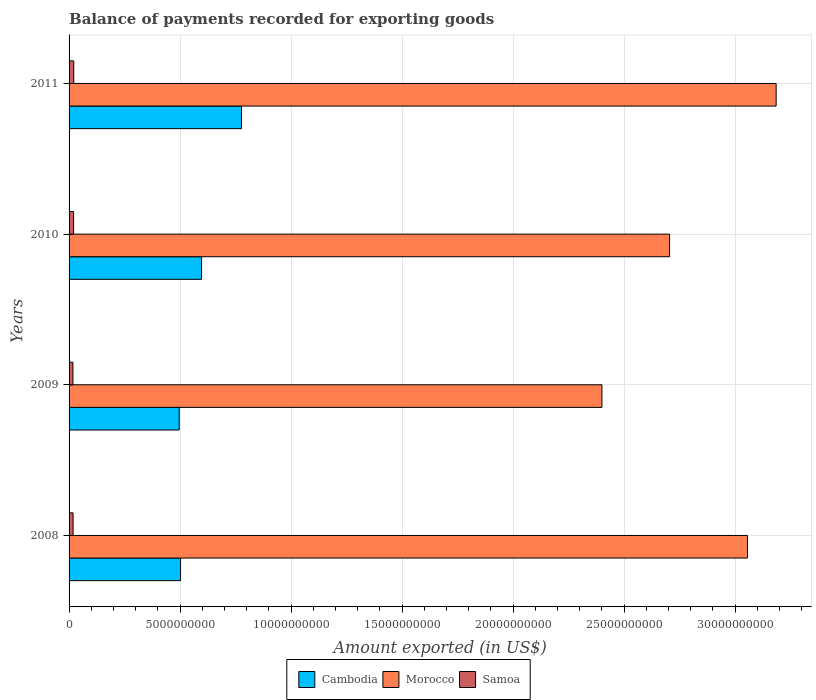How many groups of bars are there?
Provide a succinct answer. 4. Are the number of bars on each tick of the Y-axis equal?
Make the answer very short. Yes. How many bars are there on the 2nd tick from the top?
Make the answer very short. 3. How many bars are there on the 4th tick from the bottom?
Provide a succinct answer. 3. What is the amount exported in Cambodia in 2009?
Ensure brevity in your answer.  4.96e+09. Across all years, what is the maximum amount exported in Samoa?
Ensure brevity in your answer.  2.12e+08. Across all years, what is the minimum amount exported in Samoa?
Your answer should be compact. 1.74e+08. In which year was the amount exported in Morocco maximum?
Give a very brief answer. 2011. What is the total amount exported in Cambodia in the graph?
Your answer should be compact. 2.37e+1. What is the difference between the amount exported in Morocco in 2010 and that in 2011?
Provide a succinct answer. -4.80e+09. What is the difference between the amount exported in Samoa in 2010 and the amount exported in Cambodia in 2008?
Offer a terse response. -4.82e+09. What is the average amount exported in Samoa per year?
Your response must be concise. 1.92e+08. In the year 2011, what is the difference between the amount exported in Samoa and amount exported in Cambodia?
Offer a very short reply. -7.55e+09. In how many years, is the amount exported in Samoa greater than 5000000000 US$?
Make the answer very short. 0. What is the ratio of the amount exported in Cambodia in 2008 to that in 2010?
Make the answer very short. 0.84. Is the difference between the amount exported in Samoa in 2008 and 2009 greater than the difference between the amount exported in Cambodia in 2008 and 2009?
Your answer should be very brief. No. What is the difference between the highest and the second highest amount exported in Samoa?
Offer a very short reply. 8.14e+06. What is the difference between the highest and the lowest amount exported in Morocco?
Keep it short and to the point. 7.85e+09. Is the sum of the amount exported in Morocco in 2008 and 2011 greater than the maximum amount exported in Samoa across all years?
Keep it short and to the point. Yes. What does the 1st bar from the top in 2010 represents?
Keep it short and to the point. Samoa. What does the 2nd bar from the bottom in 2009 represents?
Your answer should be compact. Morocco. Is it the case that in every year, the sum of the amount exported in Morocco and amount exported in Cambodia is greater than the amount exported in Samoa?
Your answer should be compact. Yes. What is the difference between two consecutive major ticks on the X-axis?
Provide a short and direct response. 5.00e+09. Are the values on the major ticks of X-axis written in scientific E-notation?
Offer a terse response. No. Does the graph contain any zero values?
Your answer should be very brief. No. Does the graph contain grids?
Keep it short and to the point. Yes. What is the title of the graph?
Ensure brevity in your answer.  Balance of payments recorded for exporting goods. What is the label or title of the X-axis?
Provide a short and direct response. Amount exported (in US$). What is the Amount exported (in US$) of Cambodia in 2008?
Your response must be concise. 5.02e+09. What is the Amount exported (in US$) of Morocco in 2008?
Give a very brief answer. 3.06e+1. What is the Amount exported (in US$) in Samoa in 2008?
Provide a short and direct response. 1.80e+08. What is the Amount exported (in US$) of Cambodia in 2009?
Give a very brief answer. 4.96e+09. What is the Amount exported (in US$) in Morocco in 2009?
Ensure brevity in your answer.  2.40e+1. What is the Amount exported (in US$) of Samoa in 2009?
Provide a succinct answer. 1.74e+08. What is the Amount exported (in US$) in Cambodia in 2010?
Give a very brief answer. 5.97e+09. What is the Amount exported (in US$) of Morocco in 2010?
Make the answer very short. 2.70e+1. What is the Amount exported (in US$) in Samoa in 2010?
Your answer should be very brief. 2.04e+08. What is the Amount exported (in US$) in Cambodia in 2011?
Give a very brief answer. 7.76e+09. What is the Amount exported (in US$) in Morocco in 2011?
Offer a terse response. 3.18e+1. What is the Amount exported (in US$) of Samoa in 2011?
Provide a succinct answer. 2.12e+08. Across all years, what is the maximum Amount exported (in US$) of Cambodia?
Make the answer very short. 7.76e+09. Across all years, what is the maximum Amount exported (in US$) in Morocco?
Provide a short and direct response. 3.18e+1. Across all years, what is the maximum Amount exported (in US$) of Samoa?
Your response must be concise. 2.12e+08. Across all years, what is the minimum Amount exported (in US$) of Cambodia?
Your answer should be very brief. 4.96e+09. Across all years, what is the minimum Amount exported (in US$) of Morocco?
Provide a succinct answer. 2.40e+1. Across all years, what is the minimum Amount exported (in US$) in Samoa?
Your answer should be compact. 1.74e+08. What is the total Amount exported (in US$) of Cambodia in the graph?
Offer a very short reply. 2.37e+1. What is the total Amount exported (in US$) of Morocco in the graph?
Keep it short and to the point. 1.13e+11. What is the total Amount exported (in US$) of Samoa in the graph?
Make the answer very short. 7.69e+08. What is the difference between the Amount exported (in US$) of Cambodia in 2008 and that in 2009?
Provide a short and direct response. 6.08e+07. What is the difference between the Amount exported (in US$) of Morocco in 2008 and that in 2009?
Your answer should be compact. 6.56e+09. What is the difference between the Amount exported (in US$) in Samoa in 2008 and that in 2009?
Your answer should be compact. 6.53e+06. What is the difference between the Amount exported (in US$) in Cambodia in 2008 and that in 2010?
Give a very brief answer. -9.47e+08. What is the difference between the Amount exported (in US$) in Morocco in 2008 and that in 2010?
Your response must be concise. 3.51e+09. What is the difference between the Amount exported (in US$) of Samoa in 2008 and that in 2010?
Provide a short and direct response. -2.35e+07. What is the difference between the Amount exported (in US$) of Cambodia in 2008 and that in 2011?
Offer a terse response. -2.74e+09. What is the difference between the Amount exported (in US$) of Morocco in 2008 and that in 2011?
Your response must be concise. -1.29e+09. What is the difference between the Amount exported (in US$) in Samoa in 2008 and that in 2011?
Keep it short and to the point. -3.16e+07. What is the difference between the Amount exported (in US$) in Cambodia in 2009 and that in 2010?
Keep it short and to the point. -1.01e+09. What is the difference between the Amount exported (in US$) of Morocco in 2009 and that in 2010?
Ensure brevity in your answer.  -3.05e+09. What is the difference between the Amount exported (in US$) in Samoa in 2009 and that in 2010?
Your answer should be compact. -3.00e+07. What is the difference between the Amount exported (in US$) in Cambodia in 2009 and that in 2011?
Your answer should be very brief. -2.81e+09. What is the difference between the Amount exported (in US$) in Morocco in 2009 and that in 2011?
Offer a terse response. -7.85e+09. What is the difference between the Amount exported (in US$) in Samoa in 2009 and that in 2011?
Keep it short and to the point. -3.82e+07. What is the difference between the Amount exported (in US$) of Cambodia in 2010 and that in 2011?
Your answer should be very brief. -1.80e+09. What is the difference between the Amount exported (in US$) in Morocco in 2010 and that in 2011?
Your answer should be compact. -4.80e+09. What is the difference between the Amount exported (in US$) of Samoa in 2010 and that in 2011?
Keep it short and to the point. -8.14e+06. What is the difference between the Amount exported (in US$) of Cambodia in 2008 and the Amount exported (in US$) of Morocco in 2009?
Ensure brevity in your answer.  -1.90e+1. What is the difference between the Amount exported (in US$) of Cambodia in 2008 and the Amount exported (in US$) of Samoa in 2009?
Your answer should be compact. 4.85e+09. What is the difference between the Amount exported (in US$) in Morocco in 2008 and the Amount exported (in US$) in Samoa in 2009?
Provide a succinct answer. 3.04e+1. What is the difference between the Amount exported (in US$) in Cambodia in 2008 and the Amount exported (in US$) in Morocco in 2010?
Give a very brief answer. -2.20e+1. What is the difference between the Amount exported (in US$) of Cambodia in 2008 and the Amount exported (in US$) of Samoa in 2010?
Make the answer very short. 4.82e+09. What is the difference between the Amount exported (in US$) in Morocco in 2008 and the Amount exported (in US$) in Samoa in 2010?
Offer a very short reply. 3.04e+1. What is the difference between the Amount exported (in US$) of Cambodia in 2008 and the Amount exported (in US$) of Morocco in 2011?
Keep it short and to the point. -2.68e+1. What is the difference between the Amount exported (in US$) in Cambodia in 2008 and the Amount exported (in US$) in Samoa in 2011?
Offer a terse response. 4.81e+09. What is the difference between the Amount exported (in US$) of Morocco in 2008 and the Amount exported (in US$) of Samoa in 2011?
Your answer should be compact. 3.03e+1. What is the difference between the Amount exported (in US$) of Cambodia in 2009 and the Amount exported (in US$) of Morocco in 2010?
Offer a terse response. -2.21e+1. What is the difference between the Amount exported (in US$) of Cambodia in 2009 and the Amount exported (in US$) of Samoa in 2010?
Your answer should be compact. 4.76e+09. What is the difference between the Amount exported (in US$) of Morocco in 2009 and the Amount exported (in US$) of Samoa in 2010?
Keep it short and to the point. 2.38e+1. What is the difference between the Amount exported (in US$) of Cambodia in 2009 and the Amount exported (in US$) of Morocco in 2011?
Your answer should be very brief. -2.69e+1. What is the difference between the Amount exported (in US$) in Cambodia in 2009 and the Amount exported (in US$) in Samoa in 2011?
Give a very brief answer. 4.75e+09. What is the difference between the Amount exported (in US$) in Morocco in 2009 and the Amount exported (in US$) in Samoa in 2011?
Provide a short and direct response. 2.38e+1. What is the difference between the Amount exported (in US$) in Cambodia in 2010 and the Amount exported (in US$) in Morocco in 2011?
Your response must be concise. -2.59e+1. What is the difference between the Amount exported (in US$) of Cambodia in 2010 and the Amount exported (in US$) of Samoa in 2011?
Make the answer very short. 5.76e+09. What is the difference between the Amount exported (in US$) in Morocco in 2010 and the Amount exported (in US$) in Samoa in 2011?
Your answer should be very brief. 2.68e+1. What is the average Amount exported (in US$) of Cambodia per year?
Offer a very short reply. 5.93e+09. What is the average Amount exported (in US$) in Morocco per year?
Provide a short and direct response. 2.84e+1. What is the average Amount exported (in US$) of Samoa per year?
Your response must be concise. 1.92e+08. In the year 2008, what is the difference between the Amount exported (in US$) in Cambodia and Amount exported (in US$) in Morocco?
Provide a succinct answer. -2.55e+1. In the year 2008, what is the difference between the Amount exported (in US$) in Cambodia and Amount exported (in US$) in Samoa?
Your answer should be very brief. 4.84e+09. In the year 2008, what is the difference between the Amount exported (in US$) in Morocco and Amount exported (in US$) in Samoa?
Ensure brevity in your answer.  3.04e+1. In the year 2009, what is the difference between the Amount exported (in US$) in Cambodia and Amount exported (in US$) in Morocco?
Provide a succinct answer. -1.90e+1. In the year 2009, what is the difference between the Amount exported (in US$) in Cambodia and Amount exported (in US$) in Samoa?
Provide a succinct answer. 4.79e+09. In the year 2009, what is the difference between the Amount exported (in US$) of Morocco and Amount exported (in US$) of Samoa?
Provide a succinct answer. 2.38e+1. In the year 2010, what is the difference between the Amount exported (in US$) in Cambodia and Amount exported (in US$) in Morocco?
Provide a short and direct response. -2.11e+1. In the year 2010, what is the difference between the Amount exported (in US$) in Cambodia and Amount exported (in US$) in Samoa?
Provide a short and direct response. 5.76e+09. In the year 2010, what is the difference between the Amount exported (in US$) in Morocco and Amount exported (in US$) in Samoa?
Provide a succinct answer. 2.68e+1. In the year 2011, what is the difference between the Amount exported (in US$) in Cambodia and Amount exported (in US$) in Morocco?
Make the answer very short. -2.41e+1. In the year 2011, what is the difference between the Amount exported (in US$) in Cambodia and Amount exported (in US$) in Samoa?
Your response must be concise. 7.55e+09. In the year 2011, what is the difference between the Amount exported (in US$) of Morocco and Amount exported (in US$) of Samoa?
Offer a terse response. 3.16e+1. What is the ratio of the Amount exported (in US$) of Cambodia in 2008 to that in 2009?
Give a very brief answer. 1.01. What is the ratio of the Amount exported (in US$) in Morocco in 2008 to that in 2009?
Provide a succinct answer. 1.27. What is the ratio of the Amount exported (in US$) in Samoa in 2008 to that in 2009?
Offer a terse response. 1.04. What is the ratio of the Amount exported (in US$) of Cambodia in 2008 to that in 2010?
Give a very brief answer. 0.84. What is the ratio of the Amount exported (in US$) of Morocco in 2008 to that in 2010?
Give a very brief answer. 1.13. What is the ratio of the Amount exported (in US$) in Samoa in 2008 to that in 2010?
Provide a short and direct response. 0.88. What is the ratio of the Amount exported (in US$) in Cambodia in 2008 to that in 2011?
Keep it short and to the point. 0.65. What is the ratio of the Amount exported (in US$) of Morocco in 2008 to that in 2011?
Ensure brevity in your answer.  0.96. What is the ratio of the Amount exported (in US$) in Samoa in 2008 to that in 2011?
Your response must be concise. 0.85. What is the ratio of the Amount exported (in US$) in Cambodia in 2009 to that in 2010?
Your response must be concise. 0.83. What is the ratio of the Amount exported (in US$) of Morocco in 2009 to that in 2010?
Keep it short and to the point. 0.89. What is the ratio of the Amount exported (in US$) in Samoa in 2009 to that in 2010?
Offer a very short reply. 0.85. What is the ratio of the Amount exported (in US$) of Cambodia in 2009 to that in 2011?
Your response must be concise. 0.64. What is the ratio of the Amount exported (in US$) in Morocco in 2009 to that in 2011?
Provide a succinct answer. 0.75. What is the ratio of the Amount exported (in US$) in Samoa in 2009 to that in 2011?
Give a very brief answer. 0.82. What is the ratio of the Amount exported (in US$) of Cambodia in 2010 to that in 2011?
Provide a succinct answer. 0.77. What is the ratio of the Amount exported (in US$) of Morocco in 2010 to that in 2011?
Provide a short and direct response. 0.85. What is the ratio of the Amount exported (in US$) of Samoa in 2010 to that in 2011?
Your response must be concise. 0.96. What is the difference between the highest and the second highest Amount exported (in US$) of Cambodia?
Provide a short and direct response. 1.80e+09. What is the difference between the highest and the second highest Amount exported (in US$) of Morocco?
Your answer should be compact. 1.29e+09. What is the difference between the highest and the second highest Amount exported (in US$) in Samoa?
Your answer should be very brief. 8.14e+06. What is the difference between the highest and the lowest Amount exported (in US$) of Cambodia?
Make the answer very short. 2.81e+09. What is the difference between the highest and the lowest Amount exported (in US$) of Morocco?
Offer a very short reply. 7.85e+09. What is the difference between the highest and the lowest Amount exported (in US$) in Samoa?
Offer a very short reply. 3.82e+07. 